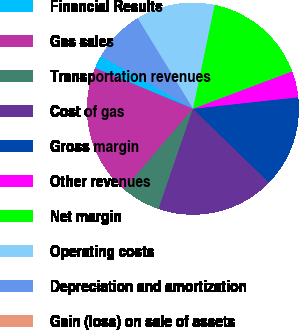Convert chart to OTSL. <chart><loc_0><loc_0><loc_500><loc_500><pie_chart><fcel>Financial Results<fcel>Gas sales<fcel>Transportation revenues<fcel>Cost of gas<fcel>Gross margin<fcel>Other revenues<fcel>Net margin<fcel>Operating costs<fcel>Depreciation and amortization<fcel>Gain (loss) on sale of assets<nl><fcel>2.0%<fcel>20.0%<fcel>6.0%<fcel>18.0%<fcel>14.0%<fcel>4.0%<fcel>16.0%<fcel>12.0%<fcel>8.0%<fcel>0.0%<nl></chart> 